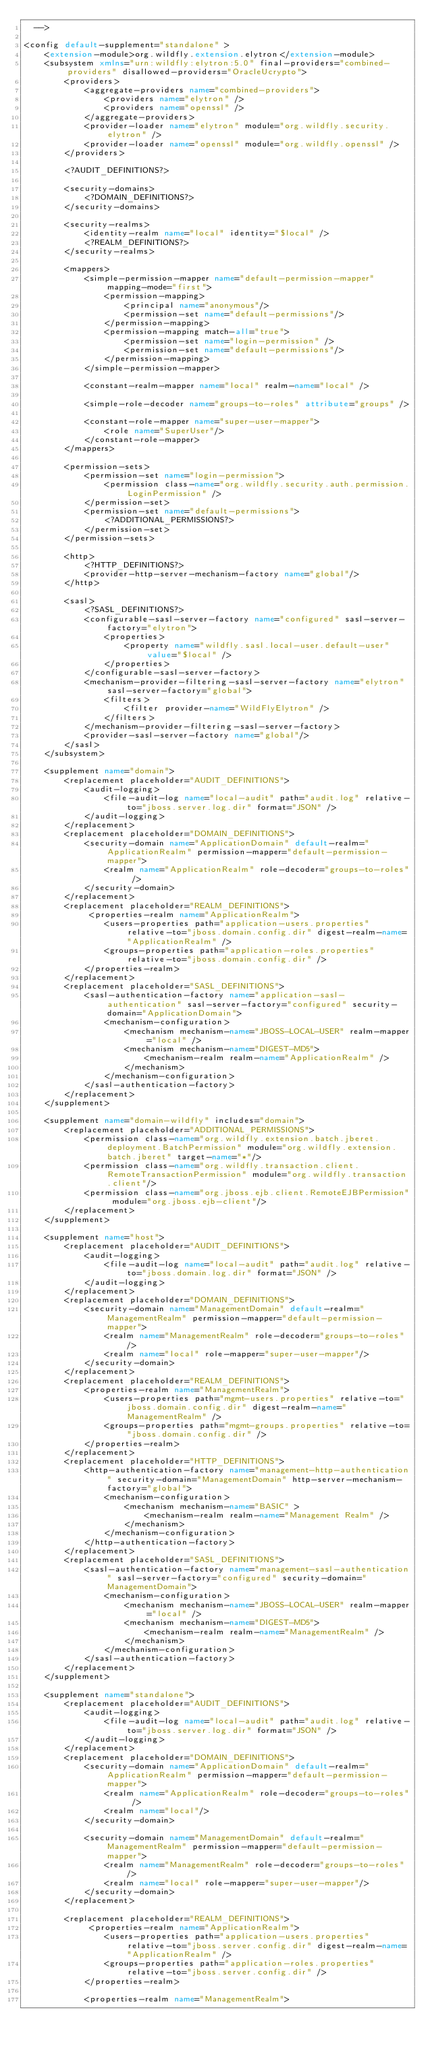Convert code to text. <code><loc_0><loc_0><loc_500><loc_500><_XML_>  -->

<config default-supplement="standalone" >
    <extension-module>org.wildfly.extension.elytron</extension-module>
    <subsystem xmlns="urn:wildfly:elytron:5.0" final-providers="combined-providers" disallowed-providers="OracleUcrypto">
        <providers>
            <aggregate-providers name="combined-providers">
                <providers name="elytron" />
                <providers name="openssl" />
            </aggregate-providers>
            <provider-loader name="elytron" module="org.wildfly.security.elytron" />
            <provider-loader name="openssl" module="org.wildfly.openssl" />
        </providers>

        <?AUDIT_DEFINITIONS?>

        <security-domains>
            <?DOMAIN_DEFINITIONS?>
        </security-domains>

        <security-realms>
            <identity-realm name="local" identity="$local" />
            <?REALM_DEFINITIONS?>
        </security-realms>

        <mappers>
            <simple-permission-mapper name="default-permission-mapper" mapping-mode="first">
                <permission-mapping>
                    <principal name="anonymous"/>
                    <permission-set name="default-permissions"/>
                </permission-mapping>
                <permission-mapping match-all="true">
                    <permission-set name="login-permission" />
                    <permission-set name="default-permissions"/>
                </permission-mapping>
            </simple-permission-mapper>

            <constant-realm-mapper name="local" realm-name="local" />

            <simple-role-decoder name="groups-to-roles" attribute="groups" />

            <constant-role-mapper name="super-user-mapper">
                <role name="SuperUser"/>
            </constant-role-mapper>
        </mappers>
        
        <permission-sets>
            <permission-set name="login-permission">
                <permission class-name="org.wildfly.security.auth.permission.LoginPermission" />
            </permission-set>
            <permission-set name="default-permissions">
                <?ADDITIONAL_PERMISSIONS?>
            </permission-set>
        </permission-sets>

        <http>
            <?HTTP_DEFINITIONS?>
            <provider-http-server-mechanism-factory name="global"/>
        </http>

        <sasl>
            <?SASL_DEFINITIONS?>
            <configurable-sasl-server-factory name="configured" sasl-server-factory="elytron">
                <properties>
                    <property name="wildfly.sasl.local-user.default-user" value="$local" />
                </properties>
            </configurable-sasl-server-factory>
            <mechanism-provider-filtering-sasl-server-factory name="elytron" sasl-server-factory="global">
                <filters>
                    <filter provider-name="WildFlyElytron" />
                </filters>
            </mechanism-provider-filtering-sasl-server-factory>
            <provider-sasl-server-factory name="global"/>
        </sasl>
    </subsystem>

    <supplement name="domain">
        <replacement placeholder="AUDIT_DEFINITIONS">
            <audit-logging>
                <file-audit-log name="local-audit" path="audit.log" relative-to="jboss.server.log.dir" format="JSON" />
            </audit-logging>
        </replacement>
        <replacement placeholder="DOMAIN_DEFINITIONS">
            <security-domain name="ApplicationDomain" default-realm="ApplicationRealm" permission-mapper="default-permission-mapper">
                <realm name="ApplicationRealm" role-decoder="groups-to-roles" />
            </security-domain>
        </replacement>
        <replacement placeholder="REALM_DEFINITIONS">
             <properties-realm name="ApplicationRealm">
                <users-properties path="application-users.properties" relative-to="jboss.domain.config.dir" digest-realm-name="ApplicationRealm" />
                <groups-properties path="application-roles.properties" relative-to="jboss.domain.config.dir" />
            </properties-realm>
        </replacement>
        <replacement placeholder="SASL_DEFINITIONS">
            <sasl-authentication-factory name="application-sasl-authentication" sasl-server-factory="configured" security-domain="ApplicationDomain">
                <mechanism-configuration>
                    <mechanism mechanism-name="JBOSS-LOCAL-USER" realm-mapper="local" />
                    <mechanism mechanism-name="DIGEST-MD5">
                        <mechanism-realm realm-name="ApplicationRealm" />
                    </mechanism>
                </mechanism-configuration>
            </sasl-authentication-factory>
        </replacement>
    </supplement>

    <supplement name="domain-wildfly" includes="domain">
        <replacement placeholder="ADDITIONAL_PERMISSIONS">
            <permission class-name="org.wildfly.extension.batch.jberet.deployment.BatchPermission" module="org.wildfly.extension.batch.jberet" target-name="*"/>
            <permission class-name="org.wildfly.transaction.client.RemoteTransactionPermission" module="org.wildfly.transaction.client"/>
            <permission class-name="org.jboss.ejb.client.RemoteEJBPermission" module="org.jboss.ejb-client"/>
        </replacement>
    </supplement>

    <supplement name="host">
        <replacement placeholder="AUDIT_DEFINITIONS">
            <audit-logging>
                <file-audit-log name="local-audit" path="audit.log" relative-to="jboss.domain.log.dir" format="JSON" />
            </audit-logging>
        </replacement>
        <replacement placeholder="DOMAIN_DEFINITIONS">
            <security-domain name="ManagementDomain" default-realm="ManagementRealm" permission-mapper="default-permission-mapper">
                <realm name="ManagementRealm" role-decoder="groups-to-roles" />
                <realm name="local" role-mapper="super-user-mapper"/>
            </security-domain>
        </replacement>
        <replacement placeholder="REALM_DEFINITIONS">
            <properties-realm name="ManagementRealm">
                <users-properties path="mgmt-users.properties" relative-to="jboss.domain.config.dir" digest-realm-name="ManagementRealm" />
                <groups-properties path="mgmt-groups.properties" relative-to="jboss.domain.config.dir" />
            </properties-realm>
        </replacement>
        <replacement placeholder="HTTP_DEFINITIONS">
            <http-authentication-factory name="management-http-authentication" security-domain="ManagementDomain" http-server-mechanism-factory="global">
                <mechanism-configuration>
                    <mechanism mechanism-name="BASIC" >
                        <mechanism-realm realm-name="Management Realm" />
                    </mechanism>
                </mechanism-configuration>
            </http-authentication-factory>
        </replacement>
        <replacement placeholder="SASL_DEFINITIONS">
            <sasl-authentication-factory name="management-sasl-authentication" sasl-server-factory="configured" security-domain="ManagementDomain">
                <mechanism-configuration>
                    <mechanism mechanism-name="JBOSS-LOCAL-USER" realm-mapper="local" />
                    <mechanism mechanism-name="DIGEST-MD5">
                        <mechanism-realm realm-name="ManagementRealm" />
                    </mechanism>
                </mechanism-configuration>
            </sasl-authentication-factory>
        </replacement>
    </supplement>

    <supplement name="standalone">
        <replacement placeholder="AUDIT_DEFINITIONS">
            <audit-logging>
                <file-audit-log name="local-audit" path="audit.log" relative-to="jboss.server.log.dir" format="JSON" />
            </audit-logging>
        </replacement>
        <replacement placeholder="DOMAIN_DEFINITIONS">
            <security-domain name="ApplicationDomain" default-realm="ApplicationRealm" permission-mapper="default-permission-mapper">
                <realm name="ApplicationRealm" role-decoder="groups-to-roles" />
                <realm name="local"/>
            </security-domain>

            <security-domain name="ManagementDomain" default-realm="ManagementRealm" permission-mapper="default-permission-mapper">
                <realm name="ManagementRealm" role-decoder="groups-to-roles" />
                <realm name="local" role-mapper="super-user-mapper"/>
            </security-domain>
        </replacement>

        <replacement placeholder="REALM_DEFINITIONS">
             <properties-realm name="ApplicationRealm">
                <users-properties path="application-users.properties" relative-to="jboss.server.config.dir" digest-realm-name="ApplicationRealm" />
                <groups-properties path="application-roles.properties" relative-to="jboss.server.config.dir" />
            </properties-realm>

            <properties-realm name="ManagementRealm"></code> 